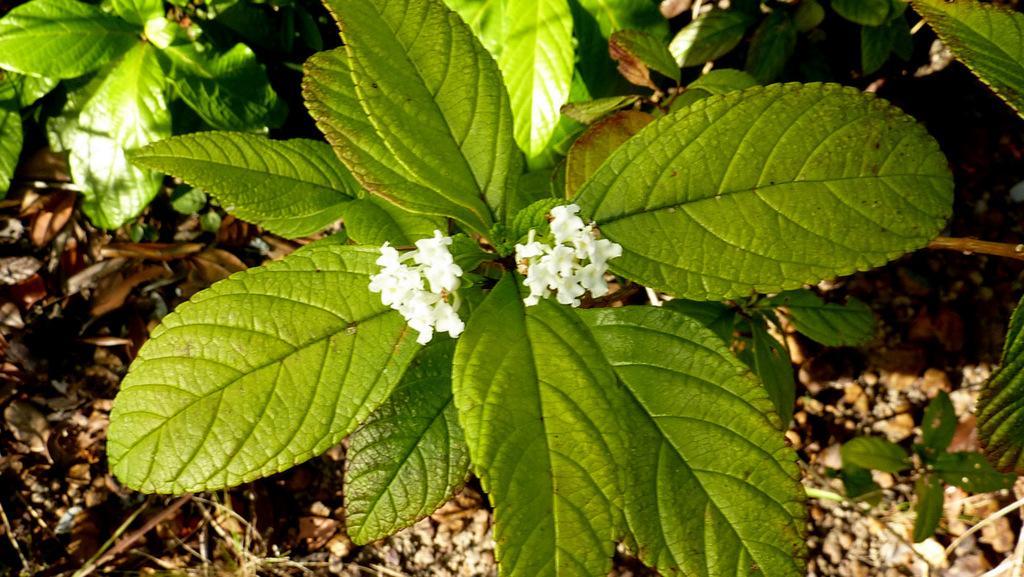Could you give a brief overview of what you see in this image? In this image there is a plant with tiny white color flowers, and in the background there are leaves. 